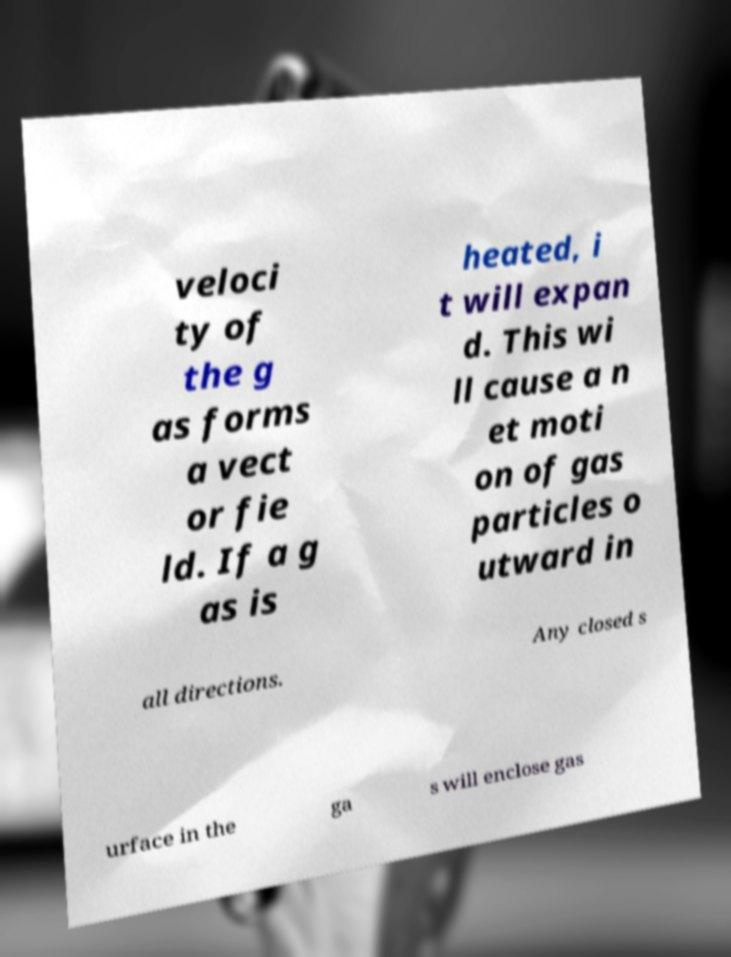Can you read and provide the text displayed in the image?This photo seems to have some interesting text. Can you extract and type it out for me? veloci ty of the g as forms a vect or fie ld. If a g as is heated, i t will expan d. This wi ll cause a n et moti on of gas particles o utward in all directions. Any closed s urface in the ga s will enclose gas 